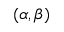Convert formula to latex. <formula><loc_0><loc_0><loc_500><loc_500>( \alpha , \beta )</formula> 